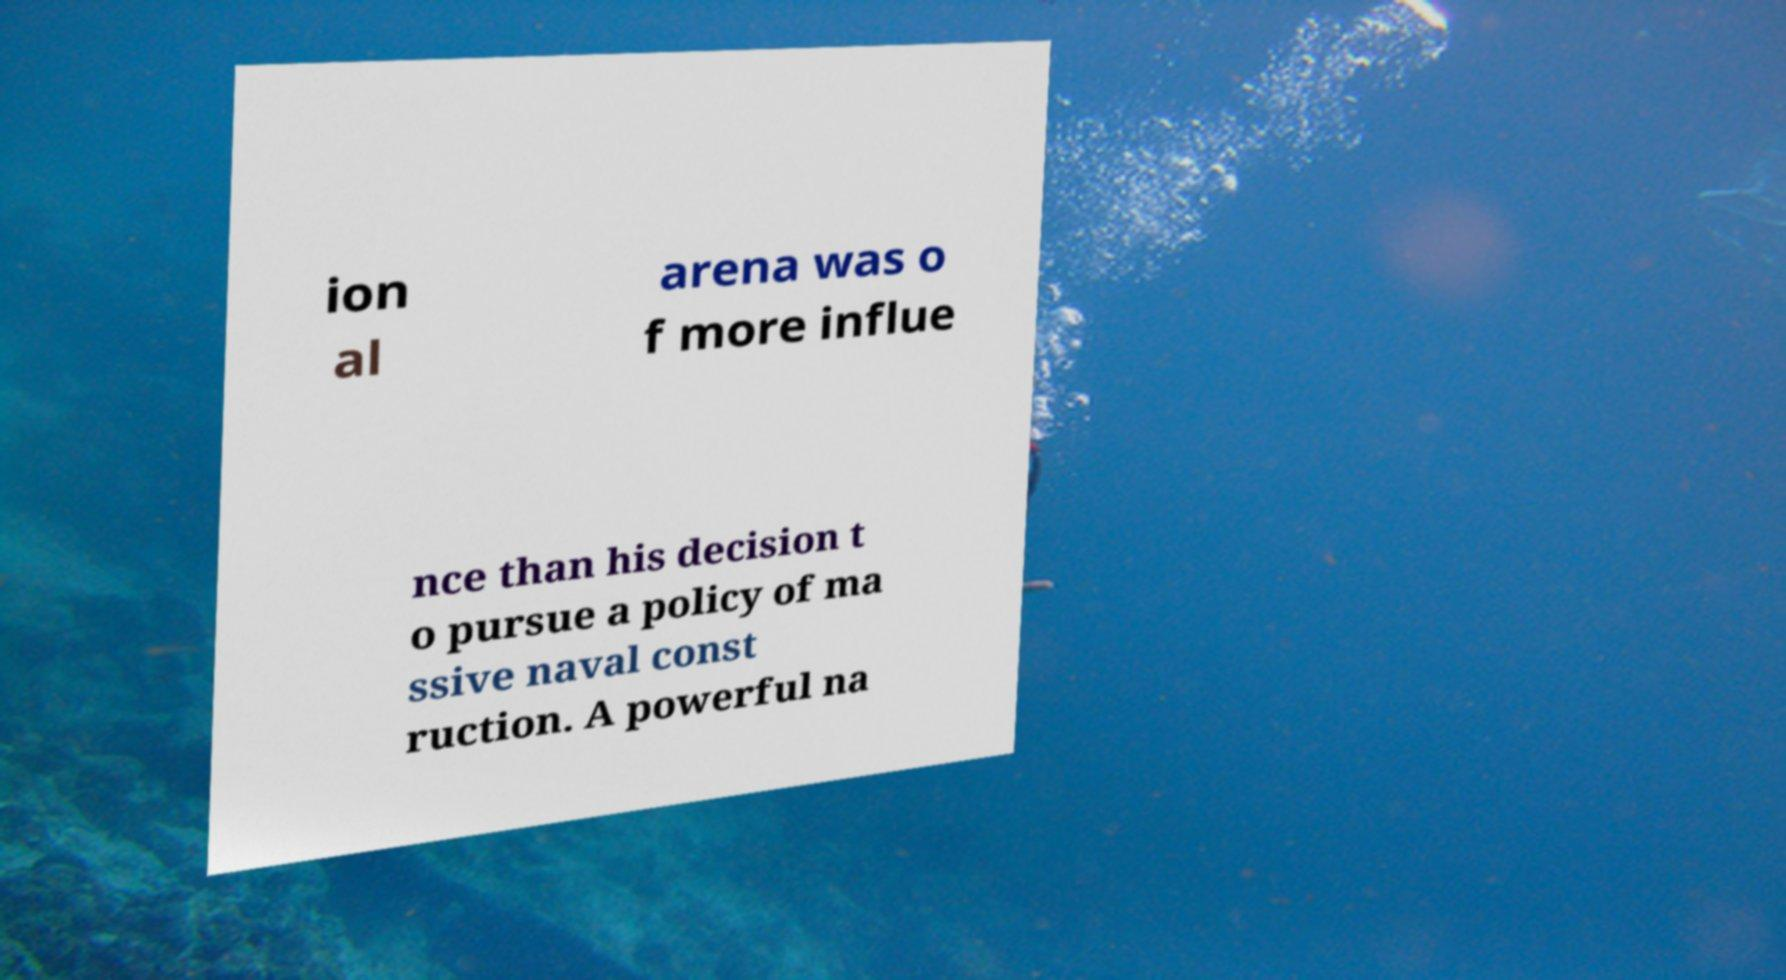Could you assist in decoding the text presented in this image and type it out clearly? ion al arena was o f more influe nce than his decision t o pursue a policy of ma ssive naval const ruction. A powerful na 